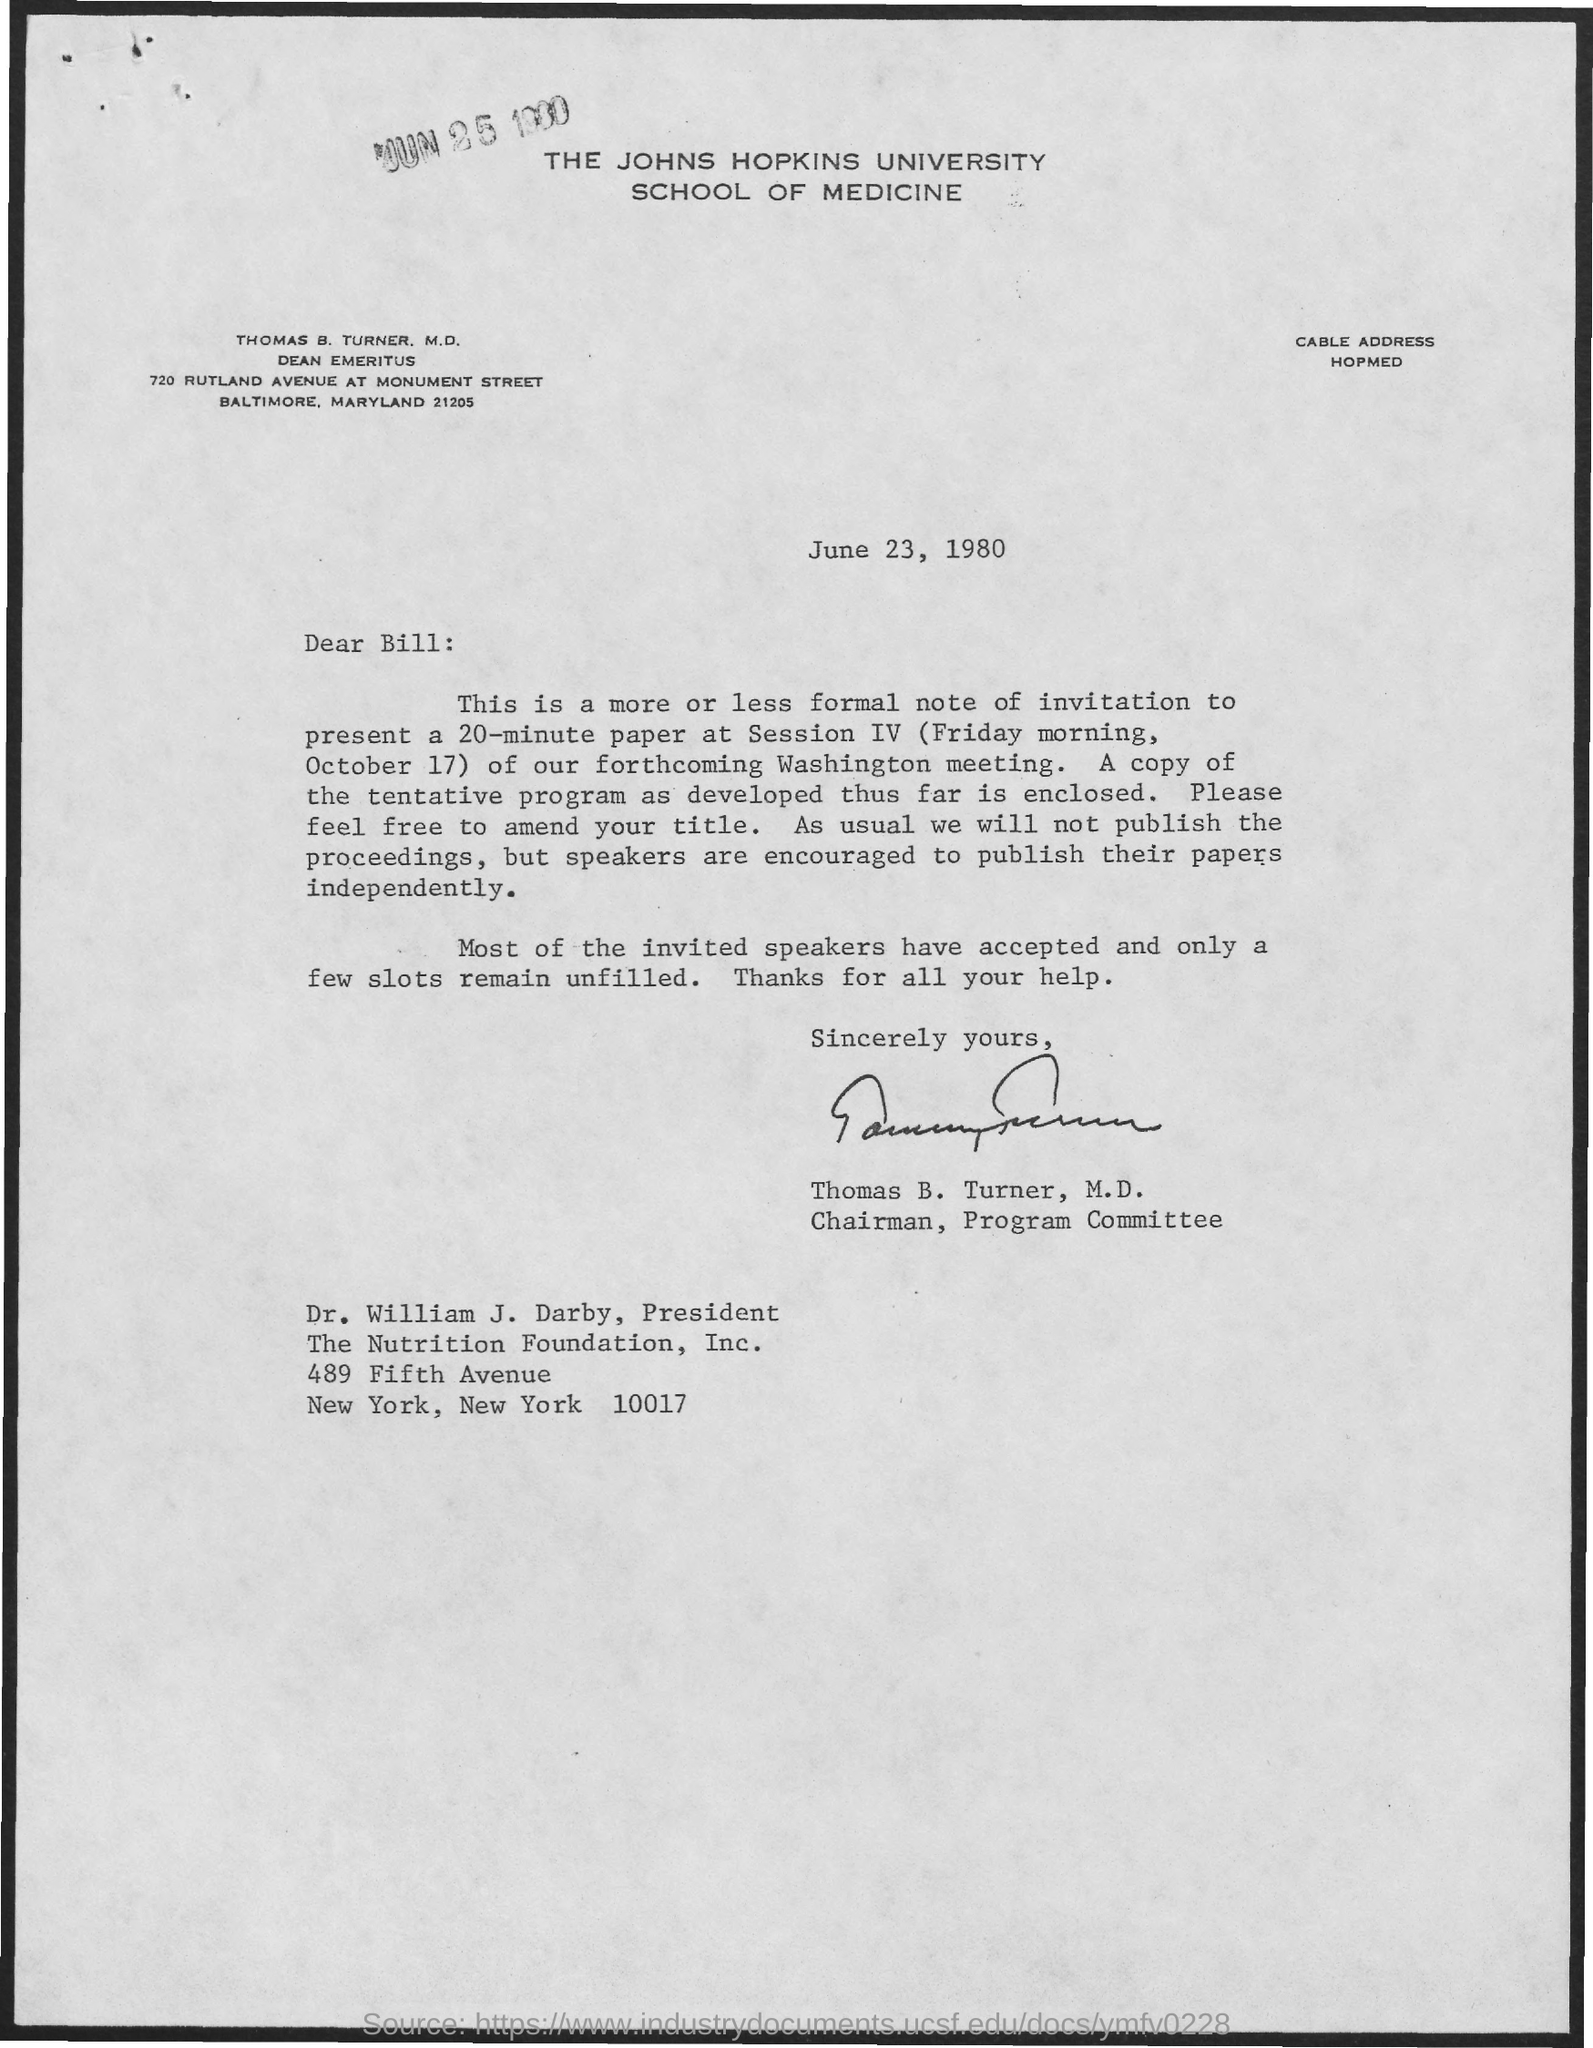Who is it from?
Provide a succinct answer. Thomas B. Turner, M.D. 